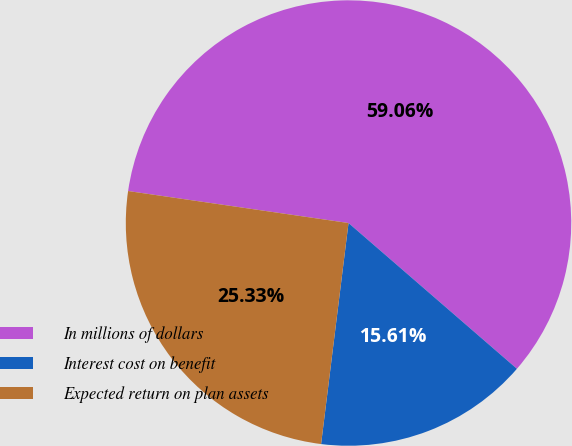Convert chart to OTSL. <chart><loc_0><loc_0><loc_500><loc_500><pie_chart><fcel>In millions of dollars<fcel>Interest cost on benefit<fcel>Expected return on plan assets<nl><fcel>59.06%<fcel>15.61%<fcel>25.33%<nl></chart> 